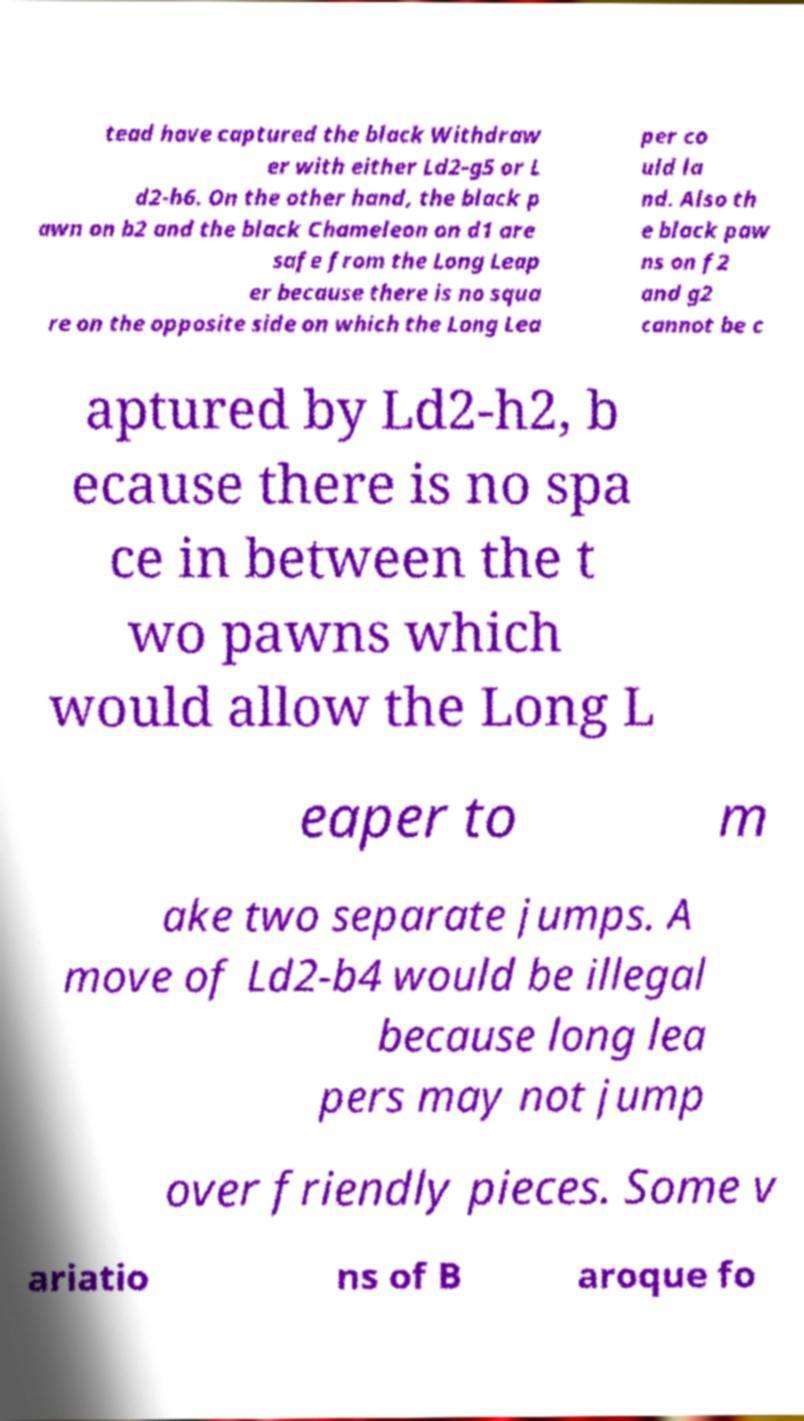Can you accurately transcribe the text from the provided image for me? tead have captured the black Withdraw er with either Ld2-g5 or L d2-h6. On the other hand, the black p awn on b2 and the black Chameleon on d1 are safe from the Long Leap er because there is no squa re on the opposite side on which the Long Lea per co uld la nd. Also th e black paw ns on f2 and g2 cannot be c aptured by Ld2-h2, b ecause there is no spa ce in between the t wo pawns which would allow the Long L eaper to m ake two separate jumps. A move of Ld2-b4 would be illegal because long lea pers may not jump over friendly pieces. Some v ariatio ns of B aroque fo 